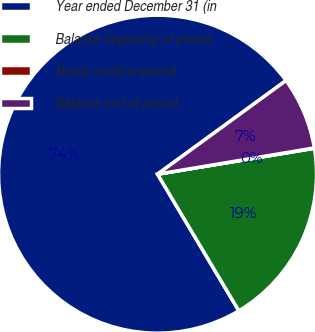<chart> <loc_0><loc_0><loc_500><loc_500><pie_chart><fcel>Year ended December 31 (in<fcel>Balance beginning of period<fcel>Newly credit-impaired<fcel>Balance end of period<nl><fcel>73.52%<fcel>19.06%<fcel>0.04%<fcel>7.38%<nl></chart> 